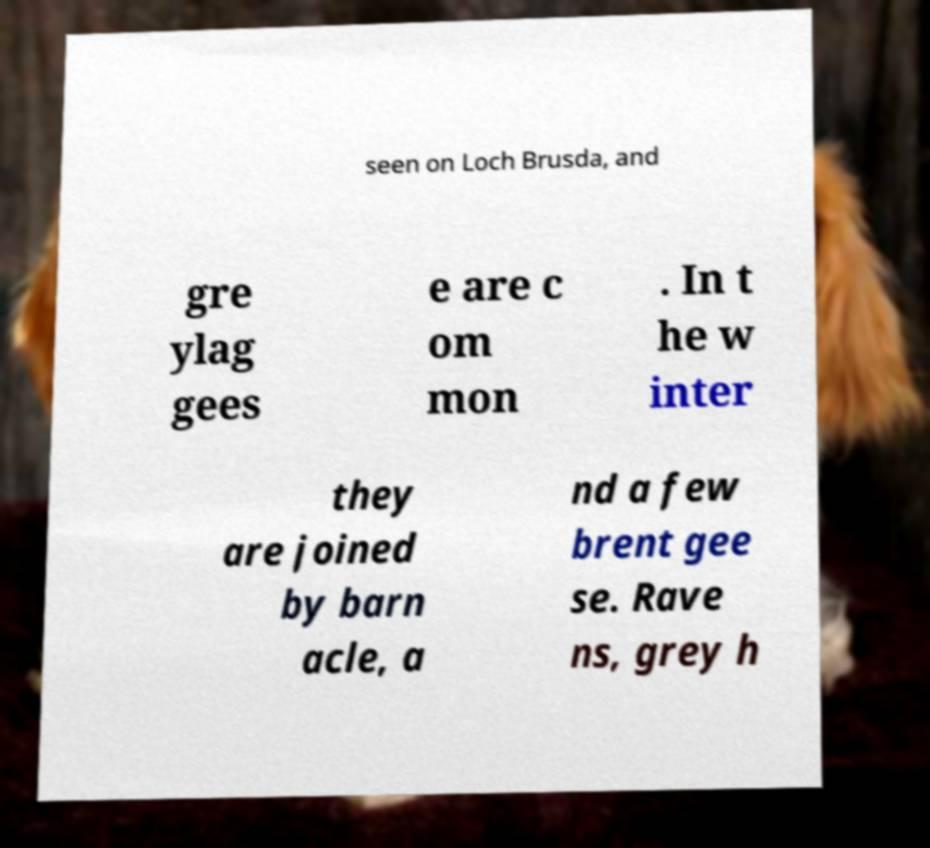Please identify and transcribe the text found in this image. seen on Loch Brusda, and gre ylag gees e are c om mon . In t he w inter they are joined by barn acle, a nd a few brent gee se. Rave ns, grey h 